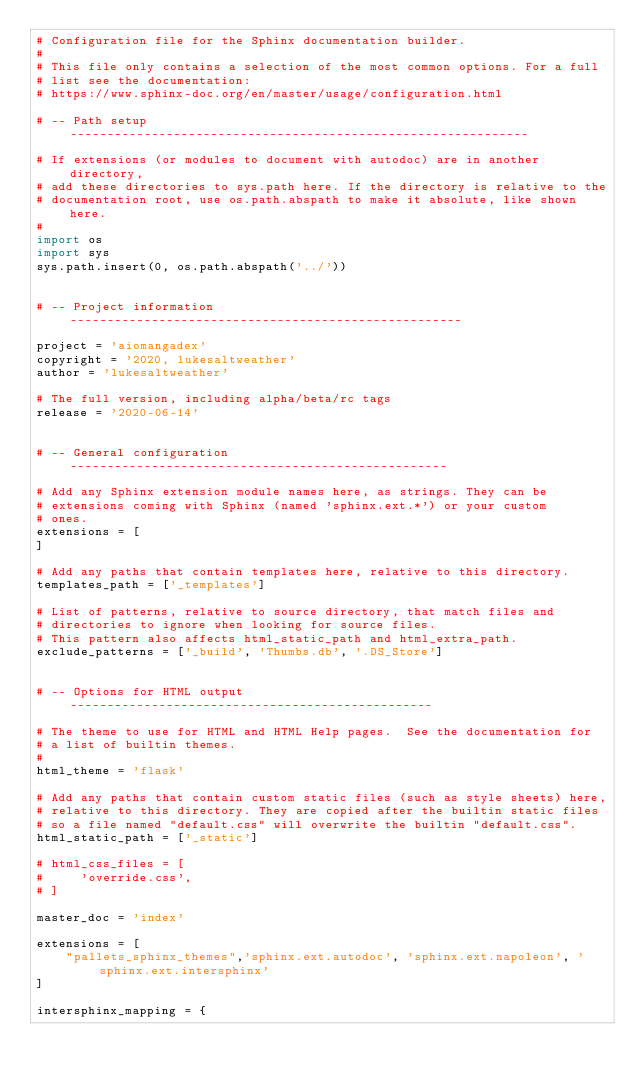Convert code to text. <code><loc_0><loc_0><loc_500><loc_500><_Python_># Configuration file for the Sphinx documentation builder.
#
# This file only contains a selection of the most common options. For a full
# list see the documentation:
# https://www.sphinx-doc.org/en/master/usage/configuration.html

# -- Path setup --------------------------------------------------------------

# If extensions (or modules to document with autodoc) are in another directory,
# add these directories to sys.path here. If the directory is relative to the
# documentation root, use os.path.abspath to make it absolute, like shown here.
#
import os
import sys
sys.path.insert(0, os.path.abspath('../'))


# -- Project information -----------------------------------------------------

project = 'aiomangadex'
copyright = '2020, lukesaltweather'
author = 'lukesaltweather'

# The full version, including alpha/beta/rc tags
release = '2020-06-14'


# -- General configuration ---------------------------------------------------

# Add any Sphinx extension module names here, as strings. They can be
# extensions coming with Sphinx (named 'sphinx.ext.*') or your custom
# ones.
extensions = [
]

# Add any paths that contain templates here, relative to this directory.
templates_path = ['_templates']

# List of patterns, relative to source directory, that match files and
# directories to ignore when looking for source files.
# This pattern also affects html_static_path and html_extra_path.
exclude_patterns = ['_build', 'Thumbs.db', '.DS_Store']


# -- Options for HTML output -------------------------------------------------

# The theme to use for HTML and HTML Help pages.  See the documentation for
# a list of builtin themes.
#
html_theme = 'flask'

# Add any paths that contain custom static files (such as style sheets) here,
# relative to this directory. They are copied after the builtin static files
# so a file named "default.css" will overwrite the builtin "default.css".
html_static_path = ['_static']

# html_css_files = [
#     'override.css',
# ]

master_doc = 'index'

extensions = [
    "pallets_sphinx_themes",'sphinx.ext.autodoc', 'sphinx.ext.napoleon', 'sphinx.ext.intersphinx'
]

intersphinx_mapping = {</code> 